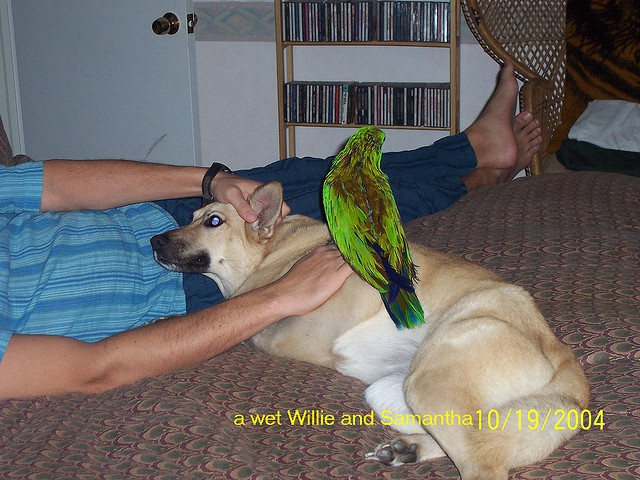Describe the objects in this image and their specific colors. I can see bed in gray and black tones, dog in gray, darkgray, and tan tones, people in gray, teal, and black tones, chair in gray, black, and maroon tones, and bird in gray, darkgreen, black, olive, and maroon tones in this image. 